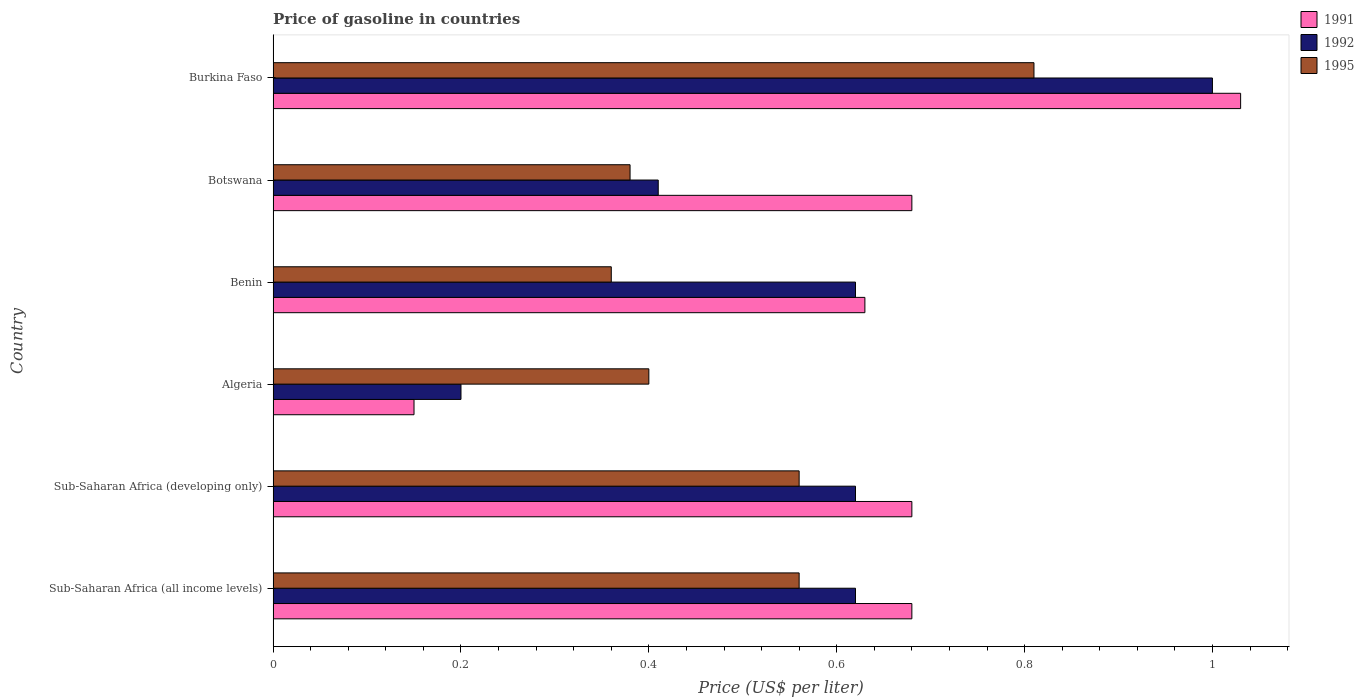How many different coloured bars are there?
Offer a terse response. 3. Are the number of bars per tick equal to the number of legend labels?
Provide a short and direct response. Yes. How many bars are there on the 1st tick from the bottom?
Offer a terse response. 3. What is the label of the 6th group of bars from the top?
Your response must be concise. Sub-Saharan Africa (all income levels). In how many cases, is the number of bars for a given country not equal to the number of legend labels?
Ensure brevity in your answer.  0. What is the price of gasoline in 1995 in Algeria?
Keep it short and to the point. 0.4. Across all countries, what is the minimum price of gasoline in 1995?
Offer a terse response. 0.36. In which country was the price of gasoline in 1995 maximum?
Provide a succinct answer. Burkina Faso. In which country was the price of gasoline in 1995 minimum?
Provide a short and direct response. Benin. What is the total price of gasoline in 1995 in the graph?
Offer a terse response. 3.07. What is the difference between the price of gasoline in 1991 in Botswana and that in Sub-Saharan Africa (developing only)?
Provide a short and direct response. 0. What is the difference between the price of gasoline in 1995 in Algeria and the price of gasoline in 1992 in Botswana?
Give a very brief answer. -0.01. What is the average price of gasoline in 1995 per country?
Make the answer very short. 0.51. What is the difference between the price of gasoline in 1991 and price of gasoline in 1992 in Benin?
Make the answer very short. 0.01. What is the ratio of the price of gasoline in 1995 in Burkina Faso to that in Sub-Saharan Africa (all income levels)?
Provide a short and direct response. 1.45. Is the price of gasoline in 1992 in Botswana less than that in Sub-Saharan Africa (developing only)?
Offer a terse response. Yes. Is the difference between the price of gasoline in 1991 in Botswana and Sub-Saharan Africa (all income levels) greater than the difference between the price of gasoline in 1992 in Botswana and Sub-Saharan Africa (all income levels)?
Your response must be concise. Yes. What is the difference between the highest and the second highest price of gasoline in 1992?
Provide a succinct answer. 0.38. What is the difference between the highest and the lowest price of gasoline in 1995?
Ensure brevity in your answer.  0.45. What does the 1st bar from the top in Algeria represents?
Provide a short and direct response. 1995. What does the 1st bar from the bottom in Sub-Saharan Africa (all income levels) represents?
Give a very brief answer. 1991. Are the values on the major ticks of X-axis written in scientific E-notation?
Provide a short and direct response. No. How are the legend labels stacked?
Ensure brevity in your answer.  Vertical. What is the title of the graph?
Keep it short and to the point. Price of gasoline in countries. What is the label or title of the X-axis?
Your answer should be very brief. Price (US$ per liter). What is the label or title of the Y-axis?
Offer a terse response. Country. What is the Price (US$ per liter) of 1991 in Sub-Saharan Africa (all income levels)?
Give a very brief answer. 0.68. What is the Price (US$ per liter) of 1992 in Sub-Saharan Africa (all income levels)?
Offer a very short reply. 0.62. What is the Price (US$ per liter) in 1995 in Sub-Saharan Africa (all income levels)?
Provide a short and direct response. 0.56. What is the Price (US$ per liter) of 1991 in Sub-Saharan Africa (developing only)?
Your answer should be very brief. 0.68. What is the Price (US$ per liter) in 1992 in Sub-Saharan Africa (developing only)?
Offer a very short reply. 0.62. What is the Price (US$ per liter) of 1995 in Sub-Saharan Africa (developing only)?
Offer a terse response. 0.56. What is the Price (US$ per liter) of 1992 in Algeria?
Provide a succinct answer. 0.2. What is the Price (US$ per liter) in 1991 in Benin?
Your answer should be very brief. 0.63. What is the Price (US$ per liter) of 1992 in Benin?
Provide a succinct answer. 0.62. What is the Price (US$ per liter) of 1995 in Benin?
Keep it short and to the point. 0.36. What is the Price (US$ per liter) in 1991 in Botswana?
Your answer should be very brief. 0.68. What is the Price (US$ per liter) of 1992 in Botswana?
Offer a very short reply. 0.41. What is the Price (US$ per liter) of 1995 in Botswana?
Give a very brief answer. 0.38. What is the Price (US$ per liter) in 1995 in Burkina Faso?
Ensure brevity in your answer.  0.81. Across all countries, what is the maximum Price (US$ per liter) in 1991?
Keep it short and to the point. 1.03. Across all countries, what is the maximum Price (US$ per liter) in 1995?
Provide a short and direct response. 0.81. Across all countries, what is the minimum Price (US$ per liter) of 1992?
Provide a short and direct response. 0.2. Across all countries, what is the minimum Price (US$ per liter) of 1995?
Your answer should be very brief. 0.36. What is the total Price (US$ per liter) in 1991 in the graph?
Offer a very short reply. 3.85. What is the total Price (US$ per liter) in 1992 in the graph?
Your response must be concise. 3.47. What is the total Price (US$ per liter) in 1995 in the graph?
Provide a short and direct response. 3.07. What is the difference between the Price (US$ per liter) of 1991 in Sub-Saharan Africa (all income levels) and that in Sub-Saharan Africa (developing only)?
Give a very brief answer. 0. What is the difference between the Price (US$ per liter) of 1992 in Sub-Saharan Africa (all income levels) and that in Sub-Saharan Africa (developing only)?
Offer a very short reply. 0. What is the difference between the Price (US$ per liter) of 1995 in Sub-Saharan Africa (all income levels) and that in Sub-Saharan Africa (developing only)?
Your answer should be very brief. 0. What is the difference between the Price (US$ per liter) of 1991 in Sub-Saharan Africa (all income levels) and that in Algeria?
Your response must be concise. 0.53. What is the difference between the Price (US$ per liter) in 1992 in Sub-Saharan Africa (all income levels) and that in Algeria?
Offer a terse response. 0.42. What is the difference between the Price (US$ per liter) of 1995 in Sub-Saharan Africa (all income levels) and that in Algeria?
Ensure brevity in your answer.  0.16. What is the difference between the Price (US$ per liter) of 1991 in Sub-Saharan Africa (all income levels) and that in Benin?
Your answer should be very brief. 0.05. What is the difference between the Price (US$ per liter) in 1992 in Sub-Saharan Africa (all income levels) and that in Benin?
Your answer should be very brief. 0. What is the difference between the Price (US$ per liter) of 1992 in Sub-Saharan Africa (all income levels) and that in Botswana?
Provide a succinct answer. 0.21. What is the difference between the Price (US$ per liter) of 1995 in Sub-Saharan Africa (all income levels) and that in Botswana?
Your answer should be compact. 0.18. What is the difference between the Price (US$ per liter) of 1991 in Sub-Saharan Africa (all income levels) and that in Burkina Faso?
Provide a short and direct response. -0.35. What is the difference between the Price (US$ per liter) of 1992 in Sub-Saharan Africa (all income levels) and that in Burkina Faso?
Ensure brevity in your answer.  -0.38. What is the difference between the Price (US$ per liter) in 1995 in Sub-Saharan Africa (all income levels) and that in Burkina Faso?
Make the answer very short. -0.25. What is the difference between the Price (US$ per liter) in 1991 in Sub-Saharan Africa (developing only) and that in Algeria?
Provide a succinct answer. 0.53. What is the difference between the Price (US$ per liter) in 1992 in Sub-Saharan Africa (developing only) and that in Algeria?
Ensure brevity in your answer.  0.42. What is the difference between the Price (US$ per liter) in 1995 in Sub-Saharan Africa (developing only) and that in Algeria?
Make the answer very short. 0.16. What is the difference between the Price (US$ per liter) in 1992 in Sub-Saharan Africa (developing only) and that in Botswana?
Provide a succinct answer. 0.21. What is the difference between the Price (US$ per liter) in 1995 in Sub-Saharan Africa (developing only) and that in Botswana?
Make the answer very short. 0.18. What is the difference between the Price (US$ per liter) of 1991 in Sub-Saharan Africa (developing only) and that in Burkina Faso?
Provide a succinct answer. -0.35. What is the difference between the Price (US$ per liter) in 1992 in Sub-Saharan Africa (developing only) and that in Burkina Faso?
Make the answer very short. -0.38. What is the difference between the Price (US$ per liter) of 1991 in Algeria and that in Benin?
Offer a very short reply. -0.48. What is the difference between the Price (US$ per liter) in 1992 in Algeria and that in Benin?
Offer a very short reply. -0.42. What is the difference between the Price (US$ per liter) in 1991 in Algeria and that in Botswana?
Ensure brevity in your answer.  -0.53. What is the difference between the Price (US$ per liter) of 1992 in Algeria and that in Botswana?
Your answer should be very brief. -0.21. What is the difference between the Price (US$ per liter) in 1995 in Algeria and that in Botswana?
Offer a terse response. 0.02. What is the difference between the Price (US$ per liter) of 1991 in Algeria and that in Burkina Faso?
Offer a terse response. -0.88. What is the difference between the Price (US$ per liter) of 1995 in Algeria and that in Burkina Faso?
Ensure brevity in your answer.  -0.41. What is the difference between the Price (US$ per liter) of 1992 in Benin and that in Botswana?
Your answer should be compact. 0.21. What is the difference between the Price (US$ per liter) in 1995 in Benin and that in Botswana?
Provide a short and direct response. -0.02. What is the difference between the Price (US$ per liter) in 1992 in Benin and that in Burkina Faso?
Your answer should be compact. -0.38. What is the difference between the Price (US$ per liter) in 1995 in Benin and that in Burkina Faso?
Provide a succinct answer. -0.45. What is the difference between the Price (US$ per liter) of 1991 in Botswana and that in Burkina Faso?
Make the answer very short. -0.35. What is the difference between the Price (US$ per liter) of 1992 in Botswana and that in Burkina Faso?
Your response must be concise. -0.59. What is the difference between the Price (US$ per liter) of 1995 in Botswana and that in Burkina Faso?
Offer a very short reply. -0.43. What is the difference between the Price (US$ per liter) of 1991 in Sub-Saharan Africa (all income levels) and the Price (US$ per liter) of 1992 in Sub-Saharan Africa (developing only)?
Ensure brevity in your answer.  0.06. What is the difference between the Price (US$ per liter) in 1991 in Sub-Saharan Africa (all income levels) and the Price (US$ per liter) in 1995 in Sub-Saharan Africa (developing only)?
Keep it short and to the point. 0.12. What is the difference between the Price (US$ per liter) in 1992 in Sub-Saharan Africa (all income levels) and the Price (US$ per liter) in 1995 in Sub-Saharan Africa (developing only)?
Your answer should be very brief. 0.06. What is the difference between the Price (US$ per liter) of 1991 in Sub-Saharan Africa (all income levels) and the Price (US$ per liter) of 1992 in Algeria?
Your answer should be very brief. 0.48. What is the difference between the Price (US$ per liter) in 1991 in Sub-Saharan Africa (all income levels) and the Price (US$ per liter) in 1995 in Algeria?
Provide a succinct answer. 0.28. What is the difference between the Price (US$ per liter) of 1992 in Sub-Saharan Africa (all income levels) and the Price (US$ per liter) of 1995 in Algeria?
Your answer should be very brief. 0.22. What is the difference between the Price (US$ per liter) of 1991 in Sub-Saharan Africa (all income levels) and the Price (US$ per liter) of 1992 in Benin?
Give a very brief answer. 0.06. What is the difference between the Price (US$ per liter) of 1991 in Sub-Saharan Africa (all income levels) and the Price (US$ per liter) of 1995 in Benin?
Your answer should be very brief. 0.32. What is the difference between the Price (US$ per liter) in 1992 in Sub-Saharan Africa (all income levels) and the Price (US$ per liter) in 1995 in Benin?
Your answer should be very brief. 0.26. What is the difference between the Price (US$ per liter) of 1991 in Sub-Saharan Africa (all income levels) and the Price (US$ per liter) of 1992 in Botswana?
Offer a terse response. 0.27. What is the difference between the Price (US$ per liter) of 1992 in Sub-Saharan Africa (all income levels) and the Price (US$ per liter) of 1995 in Botswana?
Give a very brief answer. 0.24. What is the difference between the Price (US$ per liter) in 1991 in Sub-Saharan Africa (all income levels) and the Price (US$ per liter) in 1992 in Burkina Faso?
Ensure brevity in your answer.  -0.32. What is the difference between the Price (US$ per liter) of 1991 in Sub-Saharan Africa (all income levels) and the Price (US$ per liter) of 1995 in Burkina Faso?
Your response must be concise. -0.13. What is the difference between the Price (US$ per liter) in 1992 in Sub-Saharan Africa (all income levels) and the Price (US$ per liter) in 1995 in Burkina Faso?
Your answer should be very brief. -0.19. What is the difference between the Price (US$ per liter) in 1991 in Sub-Saharan Africa (developing only) and the Price (US$ per liter) in 1992 in Algeria?
Provide a succinct answer. 0.48. What is the difference between the Price (US$ per liter) in 1991 in Sub-Saharan Africa (developing only) and the Price (US$ per liter) in 1995 in Algeria?
Ensure brevity in your answer.  0.28. What is the difference between the Price (US$ per liter) in 1992 in Sub-Saharan Africa (developing only) and the Price (US$ per liter) in 1995 in Algeria?
Give a very brief answer. 0.22. What is the difference between the Price (US$ per liter) in 1991 in Sub-Saharan Africa (developing only) and the Price (US$ per liter) in 1992 in Benin?
Provide a succinct answer. 0.06. What is the difference between the Price (US$ per liter) in 1991 in Sub-Saharan Africa (developing only) and the Price (US$ per liter) in 1995 in Benin?
Provide a short and direct response. 0.32. What is the difference between the Price (US$ per liter) in 1992 in Sub-Saharan Africa (developing only) and the Price (US$ per liter) in 1995 in Benin?
Your response must be concise. 0.26. What is the difference between the Price (US$ per liter) of 1991 in Sub-Saharan Africa (developing only) and the Price (US$ per liter) of 1992 in Botswana?
Offer a terse response. 0.27. What is the difference between the Price (US$ per liter) in 1991 in Sub-Saharan Africa (developing only) and the Price (US$ per liter) in 1995 in Botswana?
Keep it short and to the point. 0.3. What is the difference between the Price (US$ per liter) of 1992 in Sub-Saharan Africa (developing only) and the Price (US$ per liter) of 1995 in Botswana?
Make the answer very short. 0.24. What is the difference between the Price (US$ per liter) in 1991 in Sub-Saharan Africa (developing only) and the Price (US$ per liter) in 1992 in Burkina Faso?
Make the answer very short. -0.32. What is the difference between the Price (US$ per liter) of 1991 in Sub-Saharan Africa (developing only) and the Price (US$ per liter) of 1995 in Burkina Faso?
Keep it short and to the point. -0.13. What is the difference between the Price (US$ per liter) of 1992 in Sub-Saharan Africa (developing only) and the Price (US$ per liter) of 1995 in Burkina Faso?
Make the answer very short. -0.19. What is the difference between the Price (US$ per liter) of 1991 in Algeria and the Price (US$ per liter) of 1992 in Benin?
Provide a succinct answer. -0.47. What is the difference between the Price (US$ per liter) of 1991 in Algeria and the Price (US$ per liter) of 1995 in Benin?
Provide a short and direct response. -0.21. What is the difference between the Price (US$ per liter) in 1992 in Algeria and the Price (US$ per liter) in 1995 in Benin?
Your answer should be very brief. -0.16. What is the difference between the Price (US$ per liter) in 1991 in Algeria and the Price (US$ per liter) in 1992 in Botswana?
Give a very brief answer. -0.26. What is the difference between the Price (US$ per liter) in 1991 in Algeria and the Price (US$ per liter) in 1995 in Botswana?
Provide a short and direct response. -0.23. What is the difference between the Price (US$ per liter) of 1992 in Algeria and the Price (US$ per liter) of 1995 in Botswana?
Offer a very short reply. -0.18. What is the difference between the Price (US$ per liter) of 1991 in Algeria and the Price (US$ per liter) of 1992 in Burkina Faso?
Your answer should be compact. -0.85. What is the difference between the Price (US$ per liter) of 1991 in Algeria and the Price (US$ per liter) of 1995 in Burkina Faso?
Ensure brevity in your answer.  -0.66. What is the difference between the Price (US$ per liter) in 1992 in Algeria and the Price (US$ per liter) in 1995 in Burkina Faso?
Provide a short and direct response. -0.61. What is the difference between the Price (US$ per liter) in 1991 in Benin and the Price (US$ per liter) in 1992 in Botswana?
Offer a terse response. 0.22. What is the difference between the Price (US$ per liter) of 1992 in Benin and the Price (US$ per liter) of 1995 in Botswana?
Your response must be concise. 0.24. What is the difference between the Price (US$ per liter) of 1991 in Benin and the Price (US$ per liter) of 1992 in Burkina Faso?
Keep it short and to the point. -0.37. What is the difference between the Price (US$ per liter) of 1991 in Benin and the Price (US$ per liter) of 1995 in Burkina Faso?
Provide a short and direct response. -0.18. What is the difference between the Price (US$ per liter) in 1992 in Benin and the Price (US$ per liter) in 1995 in Burkina Faso?
Offer a very short reply. -0.19. What is the difference between the Price (US$ per liter) of 1991 in Botswana and the Price (US$ per liter) of 1992 in Burkina Faso?
Your answer should be very brief. -0.32. What is the difference between the Price (US$ per liter) of 1991 in Botswana and the Price (US$ per liter) of 1995 in Burkina Faso?
Your answer should be compact. -0.13. What is the difference between the Price (US$ per liter) of 1992 in Botswana and the Price (US$ per liter) of 1995 in Burkina Faso?
Give a very brief answer. -0.4. What is the average Price (US$ per liter) of 1991 per country?
Give a very brief answer. 0.64. What is the average Price (US$ per liter) in 1992 per country?
Your response must be concise. 0.58. What is the average Price (US$ per liter) in 1995 per country?
Provide a succinct answer. 0.51. What is the difference between the Price (US$ per liter) in 1991 and Price (US$ per liter) in 1992 in Sub-Saharan Africa (all income levels)?
Offer a terse response. 0.06. What is the difference between the Price (US$ per liter) of 1991 and Price (US$ per liter) of 1995 in Sub-Saharan Africa (all income levels)?
Keep it short and to the point. 0.12. What is the difference between the Price (US$ per liter) in 1991 and Price (US$ per liter) in 1992 in Sub-Saharan Africa (developing only)?
Provide a succinct answer. 0.06. What is the difference between the Price (US$ per liter) in 1991 and Price (US$ per liter) in 1995 in Sub-Saharan Africa (developing only)?
Give a very brief answer. 0.12. What is the difference between the Price (US$ per liter) in 1991 and Price (US$ per liter) in 1995 in Algeria?
Provide a succinct answer. -0.25. What is the difference between the Price (US$ per liter) of 1991 and Price (US$ per liter) of 1992 in Benin?
Provide a succinct answer. 0.01. What is the difference between the Price (US$ per liter) in 1991 and Price (US$ per liter) in 1995 in Benin?
Your response must be concise. 0.27. What is the difference between the Price (US$ per liter) of 1992 and Price (US$ per liter) of 1995 in Benin?
Make the answer very short. 0.26. What is the difference between the Price (US$ per liter) of 1991 and Price (US$ per liter) of 1992 in Botswana?
Make the answer very short. 0.27. What is the difference between the Price (US$ per liter) of 1992 and Price (US$ per liter) of 1995 in Botswana?
Keep it short and to the point. 0.03. What is the difference between the Price (US$ per liter) of 1991 and Price (US$ per liter) of 1992 in Burkina Faso?
Ensure brevity in your answer.  0.03. What is the difference between the Price (US$ per liter) of 1991 and Price (US$ per liter) of 1995 in Burkina Faso?
Provide a succinct answer. 0.22. What is the difference between the Price (US$ per liter) in 1992 and Price (US$ per liter) in 1995 in Burkina Faso?
Ensure brevity in your answer.  0.19. What is the ratio of the Price (US$ per liter) of 1991 in Sub-Saharan Africa (all income levels) to that in Sub-Saharan Africa (developing only)?
Keep it short and to the point. 1. What is the ratio of the Price (US$ per liter) in 1992 in Sub-Saharan Africa (all income levels) to that in Sub-Saharan Africa (developing only)?
Your answer should be compact. 1. What is the ratio of the Price (US$ per liter) in 1991 in Sub-Saharan Africa (all income levels) to that in Algeria?
Make the answer very short. 4.53. What is the ratio of the Price (US$ per liter) in 1992 in Sub-Saharan Africa (all income levels) to that in Algeria?
Your response must be concise. 3.1. What is the ratio of the Price (US$ per liter) of 1991 in Sub-Saharan Africa (all income levels) to that in Benin?
Your answer should be very brief. 1.08. What is the ratio of the Price (US$ per liter) of 1992 in Sub-Saharan Africa (all income levels) to that in Benin?
Give a very brief answer. 1. What is the ratio of the Price (US$ per liter) in 1995 in Sub-Saharan Africa (all income levels) to that in Benin?
Your answer should be compact. 1.56. What is the ratio of the Price (US$ per liter) of 1991 in Sub-Saharan Africa (all income levels) to that in Botswana?
Give a very brief answer. 1. What is the ratio of the Price (US$ per liter) of 1992 in Sub-Saharan Africa (all income levels) to that in Botswana?
Your response must be concise. 1.51. What is the ratio of the Price (US$ per liter) of 1995 in Sub-Saharan Africa (all income levels) to that in Botswana?
Your response must be concise. 1.47. What is the ratio of the Price (US$ per liter) of 1991 in Sub-Saharan Africa (all income levels) to that in Burkina Faso?
Provide a short and direct response. 0.66. What is the ratio of the Price (US$ per liter) in 1992 in Sub-Saharan Africa (all income levels) to that in Burkina Faso?
Make the answer very short. 0.62. What is the ratio of the Price (US$ per liter) of 1995 in Sub-Saharan Africa (all income levels) to that in Burkina Faso?
Provide a short and direct response. 0.69. What is the ratio of the Price (US$ per liter) of 1991 in Sub-Saharan Africa (developing only) to that in Algeria?
Your response must be concise. 4.53. What is the ratio of the Price (US$ per liter) of 1991 in Sub-Saharan Africa (developing only) to that in Benin?
Provide a short and direct response. 1.08. What is the ratio of the Price (US$ per liter) in 1995 in Sub-Saharan Africa (developing only) to that in Benin?
Keep it short and to the point. 1.56. What is the ratio of the Price (US$ per liter) in 1992 in Sub-Saharan Africa (developing only) to that in Botswana?
Your response must be concise. 1.51. What is the ratio of the Price (US$ per liter) in 1995 in Sub-Saharan Africa (developing only) to that in Botswana?
Your answer should be compact. 1.47. What is the ratio of the Price (US$ per liter) of 1991 in Sub-Saharan Africa (developing only) to that in Burkina Faso?
Provide a succinct answer. 0.66. What is the ratio of the Price (US$ per liter) in 1992 in Sub-Saharan Africa (developing only) to that in Burkina Faso?
Ensure brevity in your answer.  0.62. What is the ratio of the Price (US$ per liter) in 1995 in Sub-Saharan Africa (developing only) to that in Burkina Faso?
Your answer should be compact. 0.69. What is the ratio of the Price (US$ per liter) in 1991 in Algeria to that in Benin?
Keep it short and to the point. 0.24. What is the ratio of the Price (US$ per liter) in 1992 in Algeria to that in Benin?
Give a very brief answer. 0.32. What is the ratio of the Price (US$ per liter) of 1991 in Algeria to that in Botswana?
Offer a terse response. 0.22. What is the ratio of the Price (US$ per liter) in 1992 in Algeria to that in Botswana?
Ensure brevity in your answer.  0.49. What is the ratio of the Price (US$ per liter) of 1995 in Algeria to that in Botswana?
Give a very brief answer. 1.05. What is the ratio of the Price (US$ per liter) in 1991 in Algeria to that in Burkina Faso?
Offer a very short reply. 0.15. What is the ratio of the Price (US$ per liter) of 1992 in Algeria to that in Burkina Faso?
Offer a very short reply. 0.2. What is the ratio of the Price (US$ per liter) of 1995 in Algeria to that in Burkina Faso?
Your answer should be compact. 0.49. What is the ratio of the Price (US$ per liter) of 1991 in Benin to that in Botswana?
Your answer should be compact. 0.93. What is the ratio of the Price (US$ per liter) in 1992 in Benin to that in Botswana?
Offer a very short reply. 1.51. What is the ratio of the Price (US$ per liter) of 1991 in Benin to that in Burkina Faso?
Offer a very short reply. 0.61. What is the ratio of the Price (US$ per liter) of 1992 in Benin to that in Burkina Faso?
Your answer should be compact. 0.62. What is the ratio of the Price (US$ per liter) of 1995 in Benin to that in Burkina Faso?
Your answer should be very brief. 0.44. What is the ratio of the Price (US$ per liter) of 1991 in Botswana to that in Burkina Faso?
Offer a terse response. 0.66. What is the ratio of the Price (US$ per liter) in 1992 in Botswana to that in Burkina Faso?
Make the answer very short. 0.41. What is the ratio of the Price (US$ per liter) in 1995 in Botswana to that in Burkina Faso?
Keep it short and to the point. 0.47. What is the difference between the highest and the second highest Price (US$ per liter) of 1991?
Give a very brief answer. 0.35. What is the difference between the highest and the second highest Price (US$ per liter) of 1992?
Your answer should be very brief. 0.38. What is the difference between the highest and the lowest Price (US$ per liter) in 1995?
Offer a terse response. 0.45. 